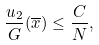<formula> <loc_0><loc_0><loc_500><loc_500>\frac { u _ { 2 } } { G } ( \overline { x } ) \leq \frac { C } { N } ,</formula> 